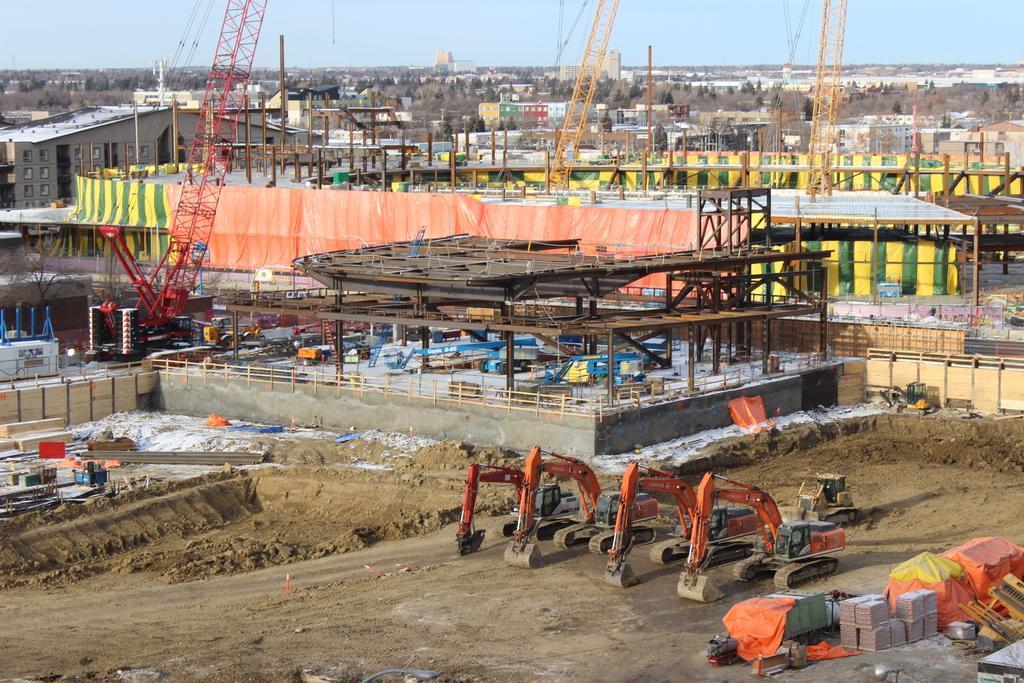Can you describe this image briefly? This is an aerial view image of a construction site, there are cranes in the front and in the back there are many buildings were going on all over the place and above its sky. 